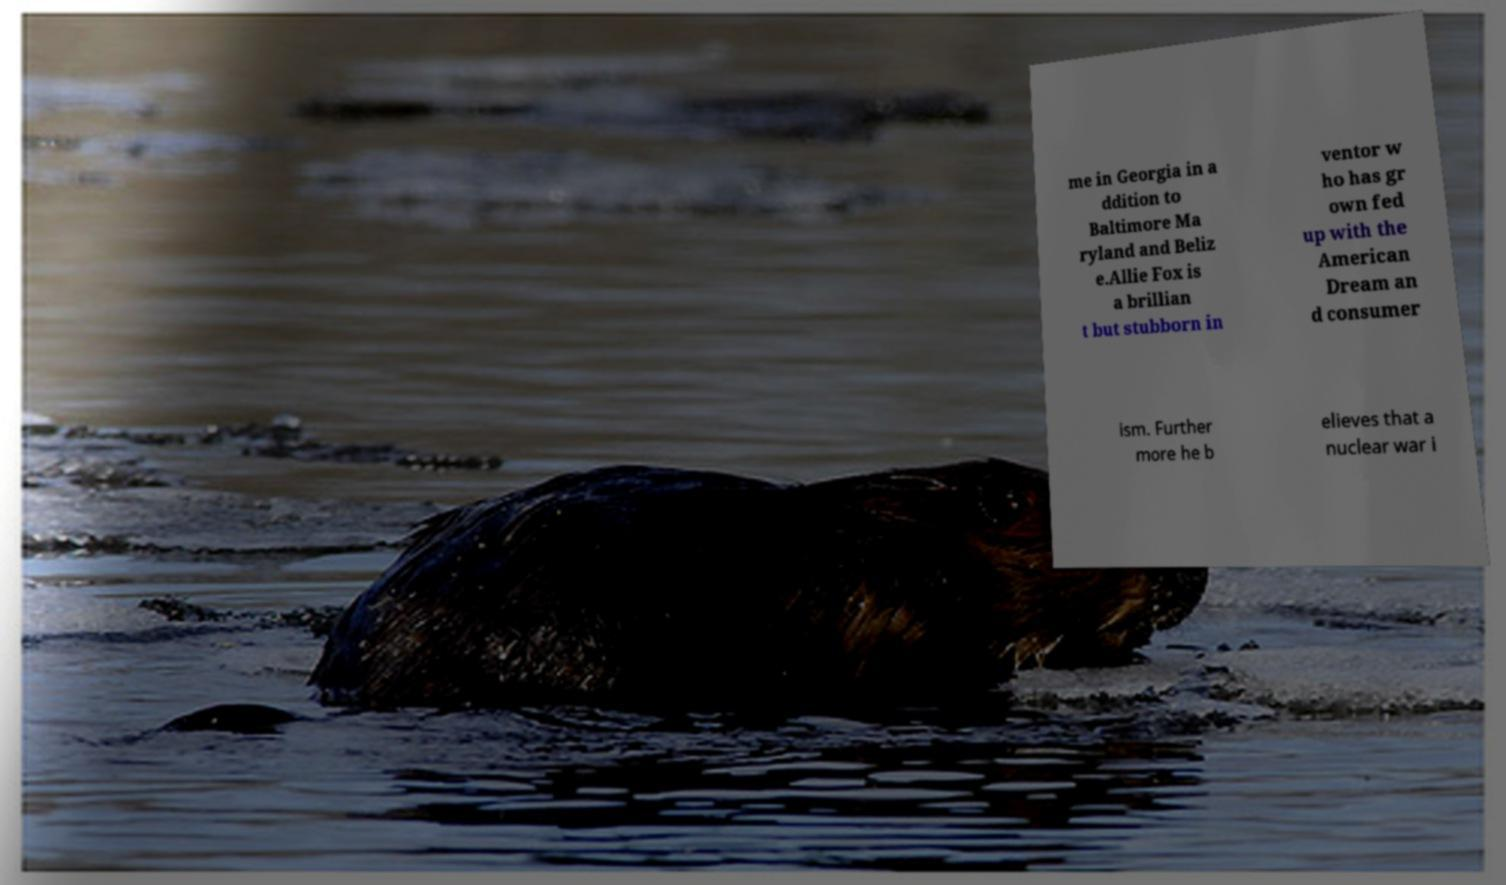I need the written content from this picture converted into text. Can you do that? me in Georgia in a ddition to Baltimore Ma ryland and Beliz e.Allie Fox is a brillian t but stubborn in ventor w ho has gr own fed up with the American Dream an d consumer ism. Further more he b elieves that a nuclear war i 